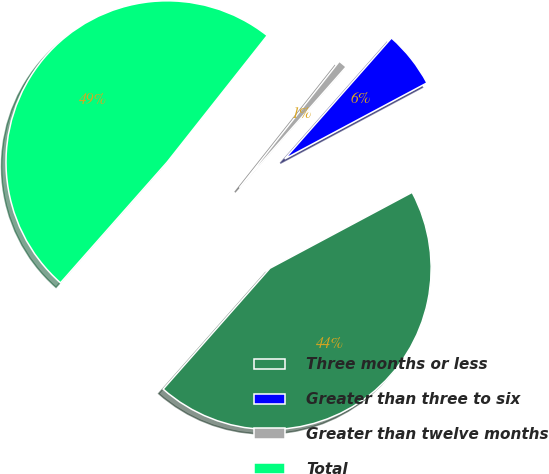<chart> <loc_0><loc_0><loc_500><loc_500><pie_chart><fcel>Three months or less<fcel>Greater than three to six<fcel>Greater than twelve months<fcel>Total<nl><fcel>44.32%<fcel>5.68%<fcel>0.87%<fcel>49.13%<nl></chart> 